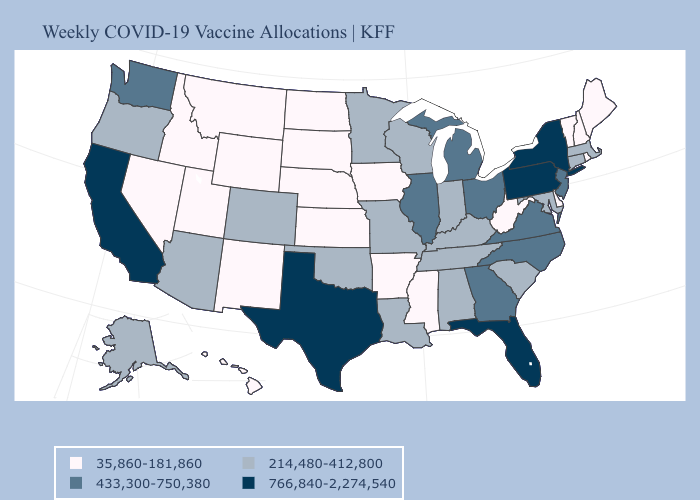What is the value of South Carolina?
Short answer required. 214,480-412,800. What is the highest value in the USA?
Answer briefly. 766,840-2,274,540. Does Vermont have the lowest value in the Northeast?
Answer briefly. Yes. Name the states that have a value in the range 433,300-750,380?
Short answer required. Georgia, Illinois, Michigan, New Jersey, North Carolina, Ohio, Virginia, Washington. What is the lowest value in states that border Florida?
Write a very short answer. 214,480-412,800. What is the lowest value in the South?
Answer briefly. 35,860-181,860. How many symbols are there in the legend?
Write a very short answer. 4. Does Missouri have the highest value in the MidWest?
Write a very short answer. No. Does Arizona have the lowest value in the USA?
Answer briefly. No. Which states hav the highest value in the Northeast?
Quick response, please. New York, Pennsylvania. What is the value of Texas?
Keep it brief. 766,840-2,274,540. What is the value of Montana?
Quick response, please. 35,860-181,860. Name the states that have a value in the range 214,480-412,800?
Keep it brief. Alabama, Alaska, Arizona, Colorado, Connecticut, Indiana, Kentucky, Louisiana, Maryland, Massachusetts, Minnesota, Missouri, Oklahoma, Oregon, South Carolina, Tennessee, Wisconsin. Name the states that have a value in the range 766,840-2,274,540?
Concise answer only. California, Florida, New York, Pennsylvania, Texas. Among the states that border New Mexico , does Texas have the highest value?
Write a very short answer. Yes. 